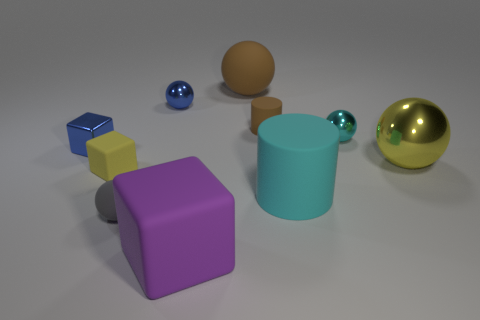Subtract all small blocks. How many blocks are left? 1 Subtract all brown cylinders. How many cylinders are left? 1 Subtract all things. Subtract all small yellow cylinders. How many objects are left? 0 Add 5 yellow rubber objects. How many yellow rubber objects are left? 6 Add 9 big brown matte objects. How many big brown matte objects exist? 10 Subtract 0 purple cylinders. How many objects are left? 10 Subtract all cylinders. How many objects are left? 8 Subtract 1 balls. How many balls are left? 4 Subtract all cyan cubes. Subtract all purple balls. How many cubes are left? 3 